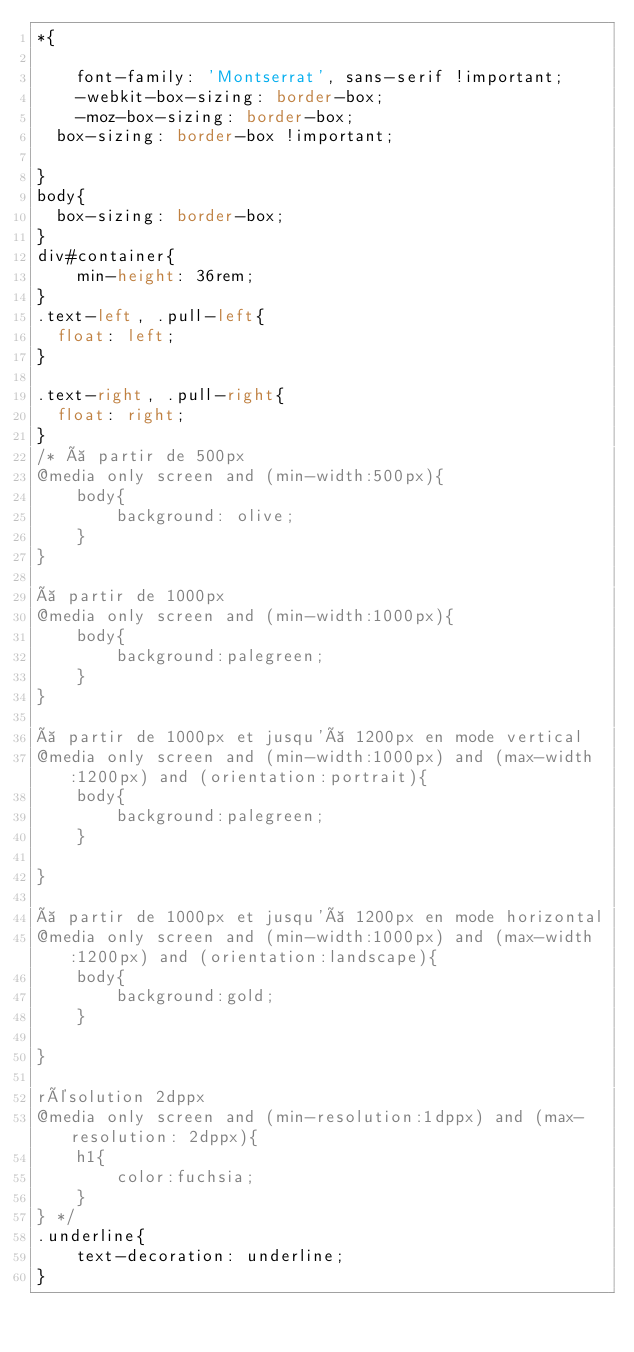<code> <loc_0><loc_0><loc_500><loc_500><_CSS_>*{

    font-family: 'Montserrat', sans-serif !important;
    -webkit-box-sizing: border-box;
    -moz-box-sizing: border-box;
	box-sizing: border-box !important;
	
}
body{
	box-sizing: border-box;
}
div#container{
    min-height: 36rem;
}
.text-left, .pull-left{
	float: left;
}

.text-right, .pull-right{
	float: right;
}
/* à partir de 500px 
@media only screen and (min-width:500px){
    body{
        background: olive;
    }
}

à partir de 1000px
@media only screen and (min-width:1000px){
    body{
        background:palegreen;
    }
}

à partir de 1000px et jusqu'à 1200px en mode vertical
@media only screen and (min-width:1000px) and (max-width:1200px) and (orientation:portrait){
    body{
        background:palegreen;
    }

}

à partir de 1000px et jusqu'à 1200px en mode horizontal
@media only screen and (min-width:1000px) and (max-width:1200px) and (orientation:landscape){
    body{
        background:gold;
    }

}

résolution 2dppx 
@media only screen and (min-resolution:1dppx) and (max-resolution: 2dppx){
    h1{
        color:fuchsia;
    }
} */
.underline{
    text-decoration: underline;
}</code> 